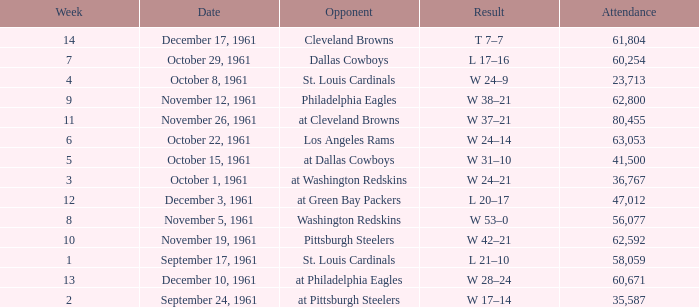Which Week has an Opponent of washington redskins, and an Attendance larger than 56,077? 0.0. Write the full table. {'header': ['Week', 'Date', 'Opponent', 'Result', 'Attendance'], 'rows': [['14', 'December 17, 1961', 'Cleveland Browns', 'T 7–7', '61,804'], ['7', 'October 29, 1961', 'Dallas Cowboys', 'L 17–16', '60,254'], ['4', 'October 8, 1961', 'St. Louis Cardinals', 'W 24–9', '23,713'], ['9', 'November 12, 1961', 'Philadelphia Eagles', 'W 38–21', '62,800'], ['11', 'November 26, 1961', 'at Cleveland Browns', 'W 37–21', '80,455'], ['6', 'October 22, 1961', 'Los Angeles Rams', 'W 24–14', '63,053'], ['5', 'October 15, 1961', 'at Dallas Cowboys', 'W 31–10', '41,500'], ['3', 'October 1, 1961', 'at Washington Redskins', 'W 24–21', '36,767'], ['12', 'December 3, 1961', 'at Green Bay Packers', 'L 20–17', '47,012'], ['8', 'November 5, 1961', 'Washington Redskins', 'W 53–0', '56,077'], ['10', 'November 19, 1961', 'Pittsburgh Steelers', 'W 42–21', '62,592'], ['1', 'September 17, 1961', 'St. Louis Cardinals', 'L 21–10', '58,059'], ['13', 'December 10, 1961', 'at Philadelphia Eagles', 'W 28–24', '60,671'], ['2', 'September 24, 1961', 'at Pittsburgh Steelers', 'W 17–14', '35,587']]} 